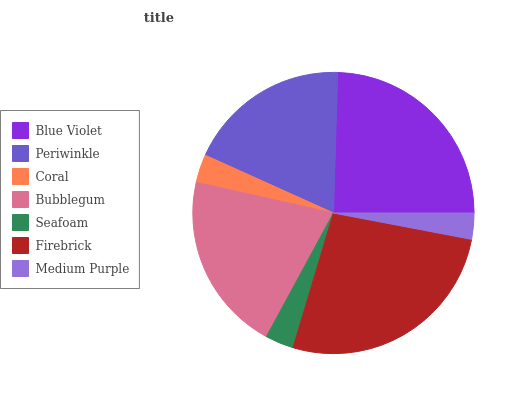Is Medium Purple the minimum?
Answer yes or no. Yes. Is Firebrick the maximum?
Answer yes or no. Yes. Is Periwinkle the minimum?
Answer yes or no. No. Is Periwinkle the maximum?
Answer yes or no. No. Is Blue Violet greater than Periwinkle?
Answer yes or no. Yes. Is Periwinkle less than Blue Violet?
Answer yes or no. Yes. Is Periwinkle greater than Blue Violet?
Answer yes or no. No. Is Blue Violet less than Periwinkle?
Answer yes or no. No. Is Periwinkle the high median?
Answer yes or no. Yes. Is Periwinkle the low median?
Answer yes or no. Yes. Is Firebrick the high median?
Answer yes or no. No. Is Bubblegum the low median?
Answer yes or no. No. 